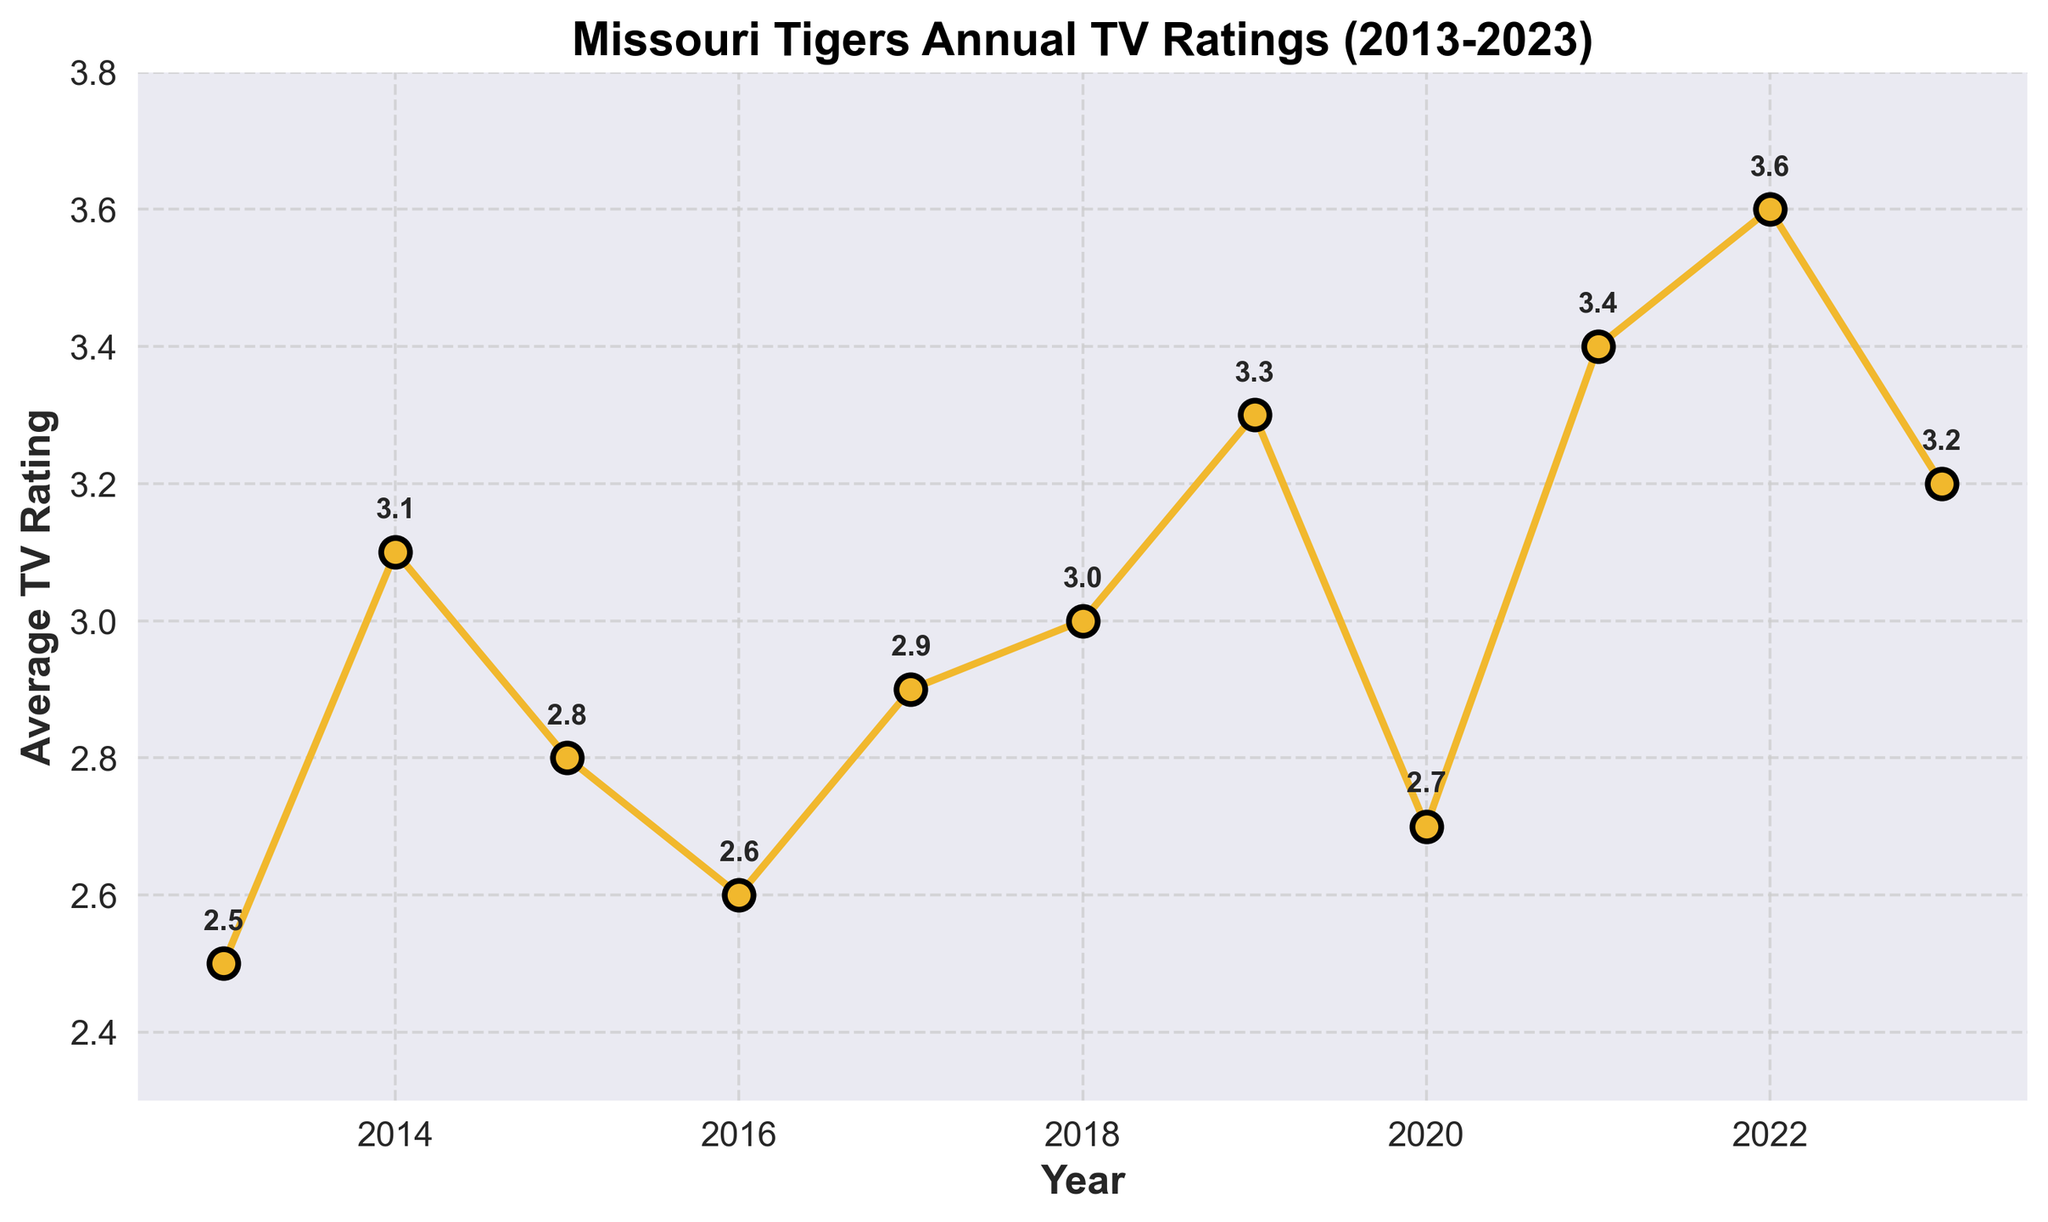What's the title of the plot? The title is usually displayed at the top of the chart and describes the content of the plot. Here, it says "Missouri Tigers Annual TV Ratings (2013-2023)" which indicates the plot is showing the average TV ratings for Missouri Tigers games over a span of ten years.
Answer: Missouri Tigers Annual TV Ratings (2013-2023) What is the average TV rating for 2019? Look for the data point marked for the year 2019 on the x-axis and see the corresponding y-value. In this plot, it shows that the rating for 2019 is 3.3.
Answer: 3.3 Between which years did the average TV rating see the highest increase? To determine this, identify the years with the highest positive difference between consecutive years. By examining the plot, it is evident that the highest increase occurred between 2020 (2.7) and 2021 (3.4), which is a difference of 0.7.
Answer: 2020 to 2021 In which year did the average TV rating slightly drop after a period of increase? Identify the period with a rating drop after consistent increases. Around 2023 (3.2) a slight drop is seen following the increase up to 2022 (3.6).
Answer: 2023 What trend is observed in the TV ratings from 2020 to 2022? Evaluate the trend by examining the data points between these years. The ratings rose from 2.7 in 2020 to 3.4 in 2021 and further to 3.6 in 2022, which shows an upward trend.
Answer: Upward trend What has been the average (mean) TV rating over the entire decade (2013-2023)? Calculate the mean by adding up all the ratings and dividing by the number of years (11). The sum is 32.1, so the average is 32.1 / 11 which is approximately 2.92.
Answer: 2.92 Which year had the highest TV rating for the Missouri Tigers? Identify the tallest data point on the y-axis labelled for each year. 2022 stands out with the highest rating of 3.6.
Answer: 2022 How does the TV rating in 2018 compare to 2023? Compare the data points for these two years. The rating for 2018 is 3.0 while for 2023 it is 3.2, showing that the average TV rating increased by 0.2 between these years.
Answer: 3.2 > 3.0 By how much did the average TV rating change from 2014 to 2015? Calculate the difference between the two years. The TV rating in 2014 is 3.1 and in 2015 is 2.8. The decrease is 3.1 - 2.8 which is 0.3.
Answer: Decreased by 0.3 What year had the lowest TV rating and what was it? Identify the smallest value on the y-axis and the corresponding year. The lowest rating is in 2016 at 2.6.
Answer: 2016, 2.6 